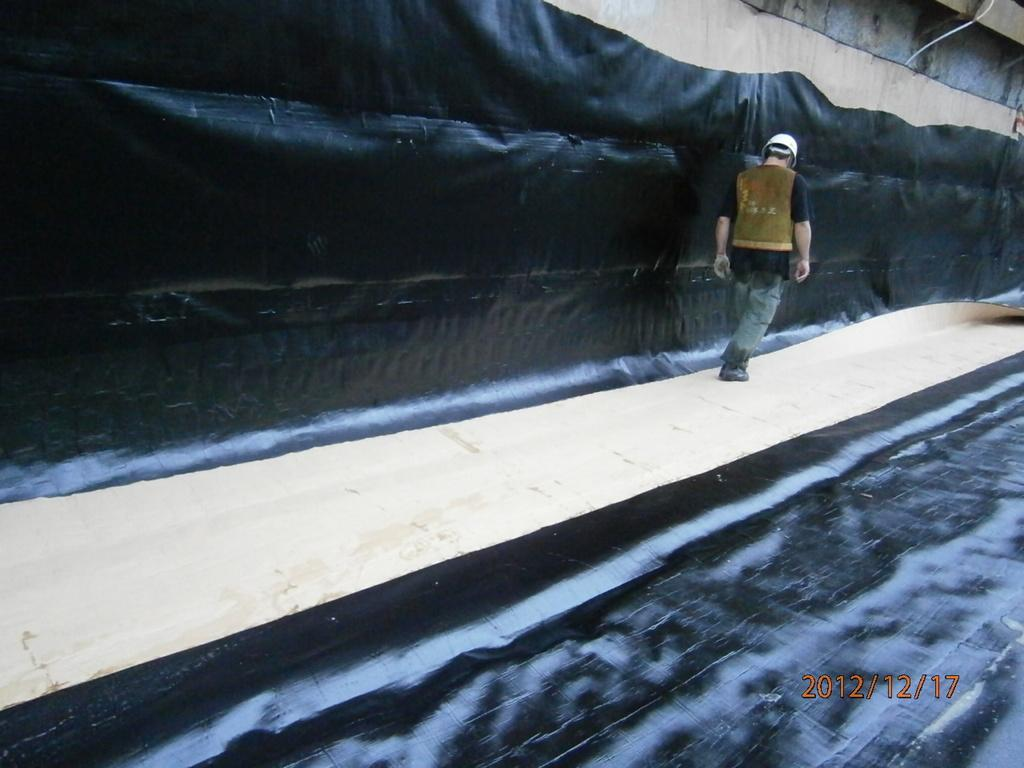What is the person in the image wearing on their head? The person is wearing a helmet in the image. What is the person doing in the image? The person is walking in the image. Can you describe the wall in the image? The wall in the image has a black color. What is present in the right corner of the image? There is a watermark in the right corner of the image. How is the floor patterned in the image? The floor has a cream and black color pattern in the image. What type of quince is being served for breakfast in the image? There is no quince or breakfast present in the image; it features a person walking with a helmet on. 